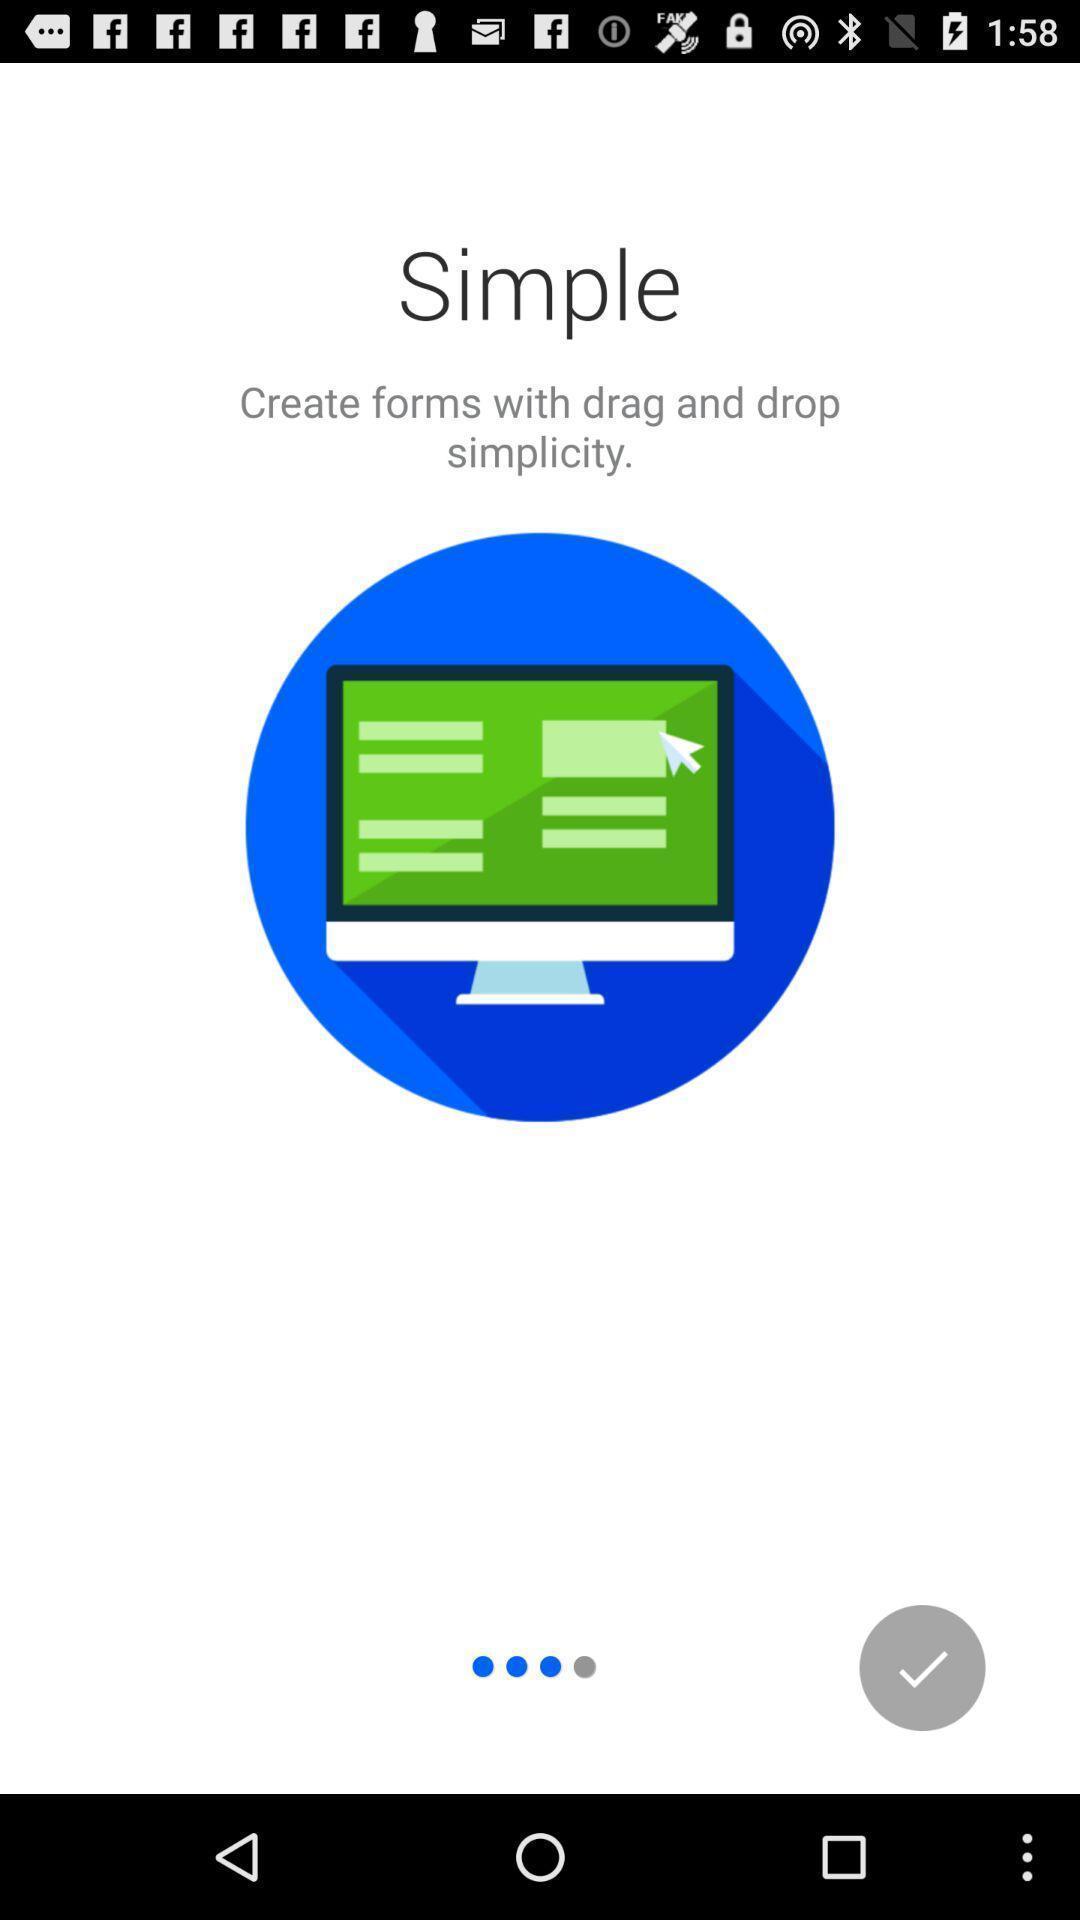What details can you identify in this image? Starting page for a forms creating app. 